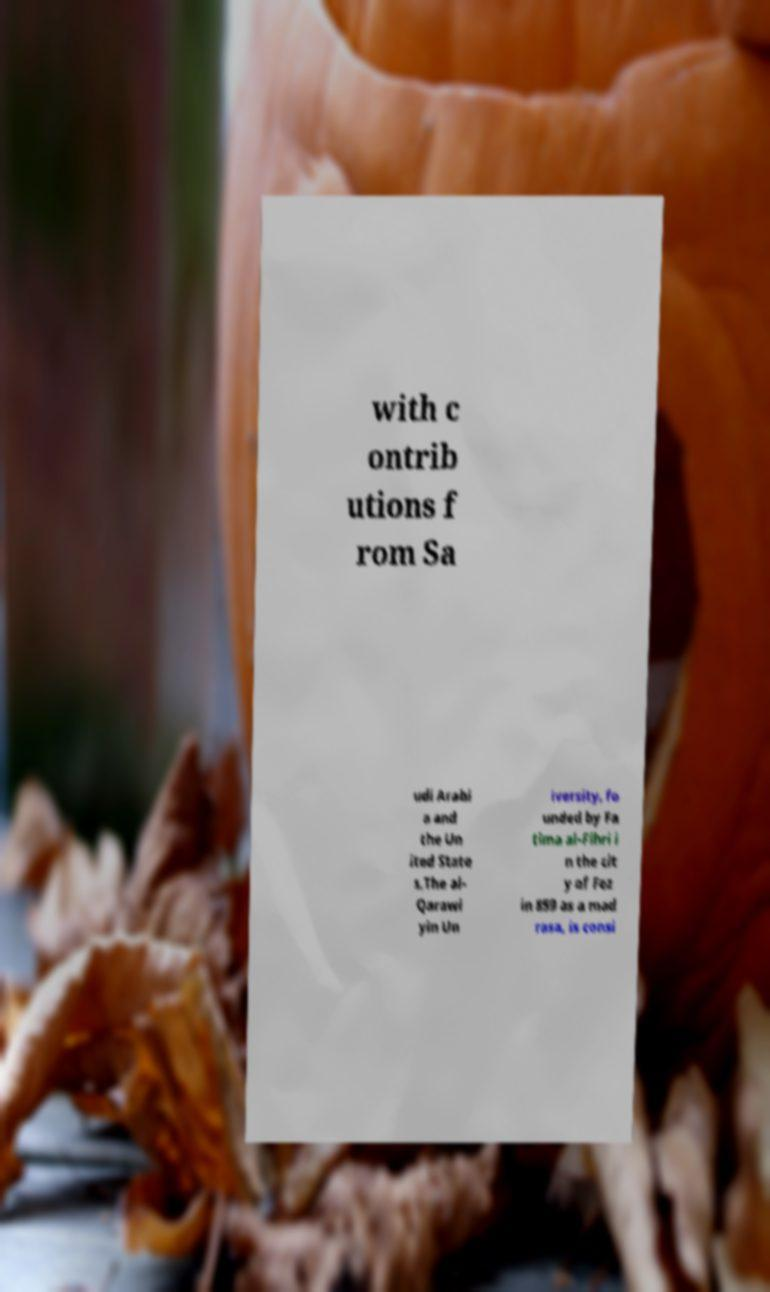Can you accurately transcribe the text from the provided image for me? with c ontrib utions f rom Sa udi Arabi a and the Un ited State s.The al- Qarawi yin Un iversity, fo unded by Fa tima al-Fihri i n the cit y of Fez in 859 as a mad rasa, is consi 